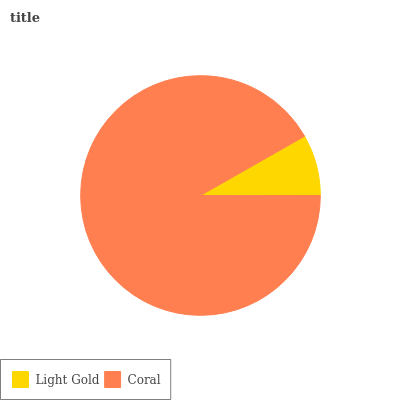Is Light Gold the minimum?
Answer yes or no. Yes. Is Coral the maximum?
Answer yes or no. Yes. Is Coral the minimum?
Answer yes or no. No. Is Coral greater than Light Gold?
Answer yes or no. Yes. Is Light Gold less than Coral?
Answer yes or no. Yes. Is Light Gold greater than Coral?
Answer yes or no. No. Is Coral less than Light Gold?
Answer yes or no. No. Is Coral the high median?
Answer yes or no. Yes. Is Light Gold the low median?
Answer yes or no. Yes. Is Light Gold the high median?
Answer yes or no. No. Is Coral the low median?
Answer yes or no. No. 